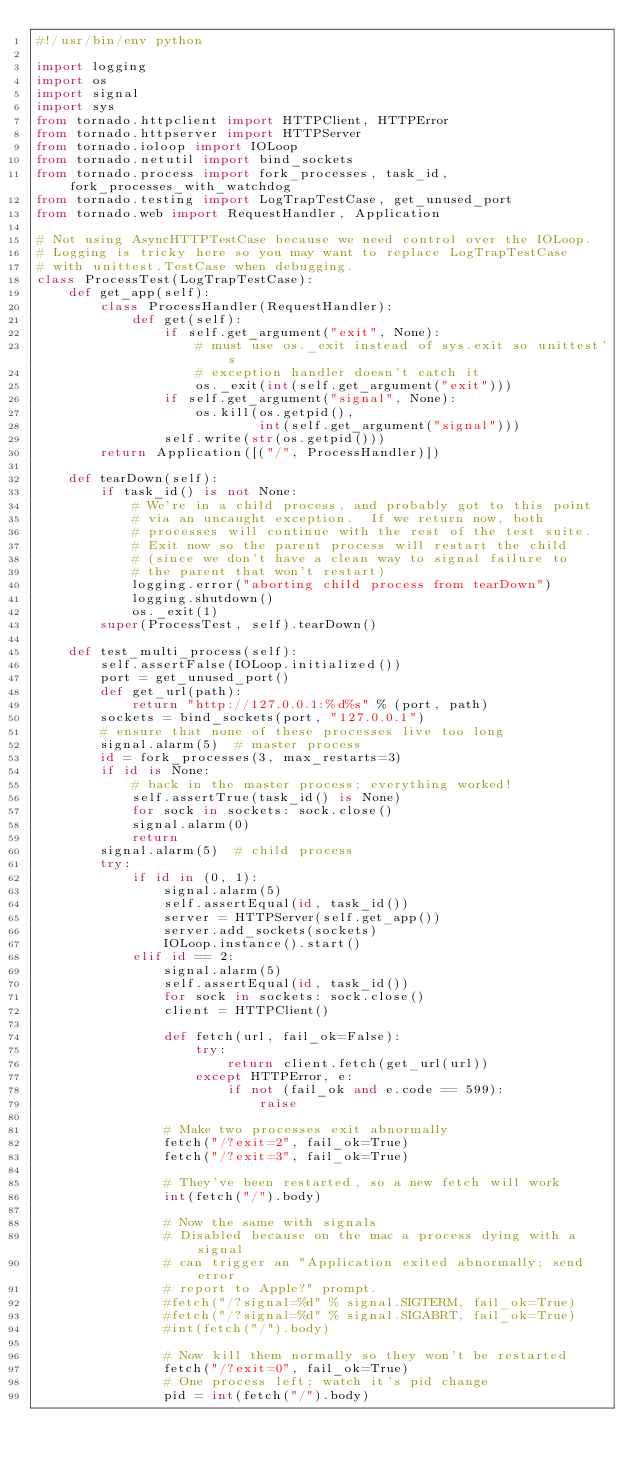Convert code to text. <code><loc_0><loc_0><loc_500><loc_500><_Python_>#!/usr/bin/env python

import logging
import os
import signal
import sys
from tornado.httpclient import HTTPClient, HTTPError
from tornado.httpserver import HTTPServer
from tornado.ioloop import IOLoop
from tornado.netutil import bind_sockets
from tornado.process import fork_processes, task_id, fork_processes_with_watchdog
from tornado.testing import LogTrapTestCase, get_unused_port
from tornado.web import RequestHandler, Application

# Not using AsyncHTTPTestCase because we need control over the IOLoop.
# Logging is tricky here so you may want to replace LogTrapTestCase
# with unittest.TestCase when debugging.
class ProcessTest(LogTrapTestCase):
    def get_app(self):
        class ProcessHandler(RequestHandler):
            def get(self):
                if self.get_argument("exit", None):
                    # must use os._exit instead of sys.exit so unittest's
                    # exception handler doesn't catch it
                    os._exit(int(self.get_argument("exit")))
                if self.get_argument("signal", None):
                    os.kill(os.getpid(),
                            int(self.get_argument("signal")))
                self.write(str(os.getpid()))
        return Application([("/", ProcessHandler)])

    def tearDown(self):
        if task_id() is not None:
            # We're in a child process, and probably got to this point
            # via an uncaught exception.  If we return now, both
            # processes will continue with the rest of the test suite.
            # Exit now so the parent process will restart the child
            # (since we don't have a clean way to signal failure to
            # the parent that won't restart)
            logging.error("aborting child process from tearDown")
            logging.shutdown()
            os._exit(1)
        super(ProcessTest, self).tearDown()

    def test_multi_process(self):
        self.assertFalse(IOLoop.initialized())
        port = get_unused_port()
        def get_url(path):
            return "http://127.0.0.1:%d%s" % (port, path)
        sockets = bind_sockets(port, "127.0.0.1")
        # ensure that none of these processes live too long
        signal.alarm(5)  # master process
        id = fork_processes(3, max_restarts=3)
        if id is None:
            # back in the master process; everything worked!
            self.assertTrue(task_id() is None)
            for sock in sockets: sock.close()
            signal.alarm(0)
            return
        signal.alarm(5)  # child process
        try:
            if id in (0, 1):
                signal.alarm(5)
                self.assertEqual(id, task_id())
                server = HTTPServer(self.get_app())
                server.add_sockets(sockets)
                IOLoop.instance().start()
            elif id == 2:
                signal.alarm(5)
                self.assertEqual(id, task_id())
                for sock in sockets: sock.close()
                client = HTTPClient()

                def fetch(url, fail_ok=False):
                    try:
                        return client.fetch(get_url(url))
                    except HTTPError, e:
                        if not (fail_ok and e.code == 599):
                            raise

                # Make two processes exit abnormally
                fetch("/?exit=2", fail_ok=True)
                fetch("/?exit=3", fail_ok=True)

                # They've been restarted, so a new fetch will work
                int(fetch("/").body)

                # Now the same with signals
                # Disabled because on the mac a process dying with a signal
                # can trigger an "Application exited abnormally; send error
                # report to Apple?" prompt.
                #fetch("/?signal=%d" % signal.SIGTERM, fail_ok=True)
                #fetch("/?signal=%d" % signal.SIGABRT, fail_ok=True)
                #int(fetch("/").body)

                # Now kill them normally so they won't be restarted
                fetch("/?exit=0", fail_ok=True)
                # One process left; watch it's pid change
                pid = int(fetch("/").body)</code> 